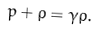<formula> <loc_0><loc_0><loc_500><loc_500>p + \rho = \gamma \rho .</formula> 